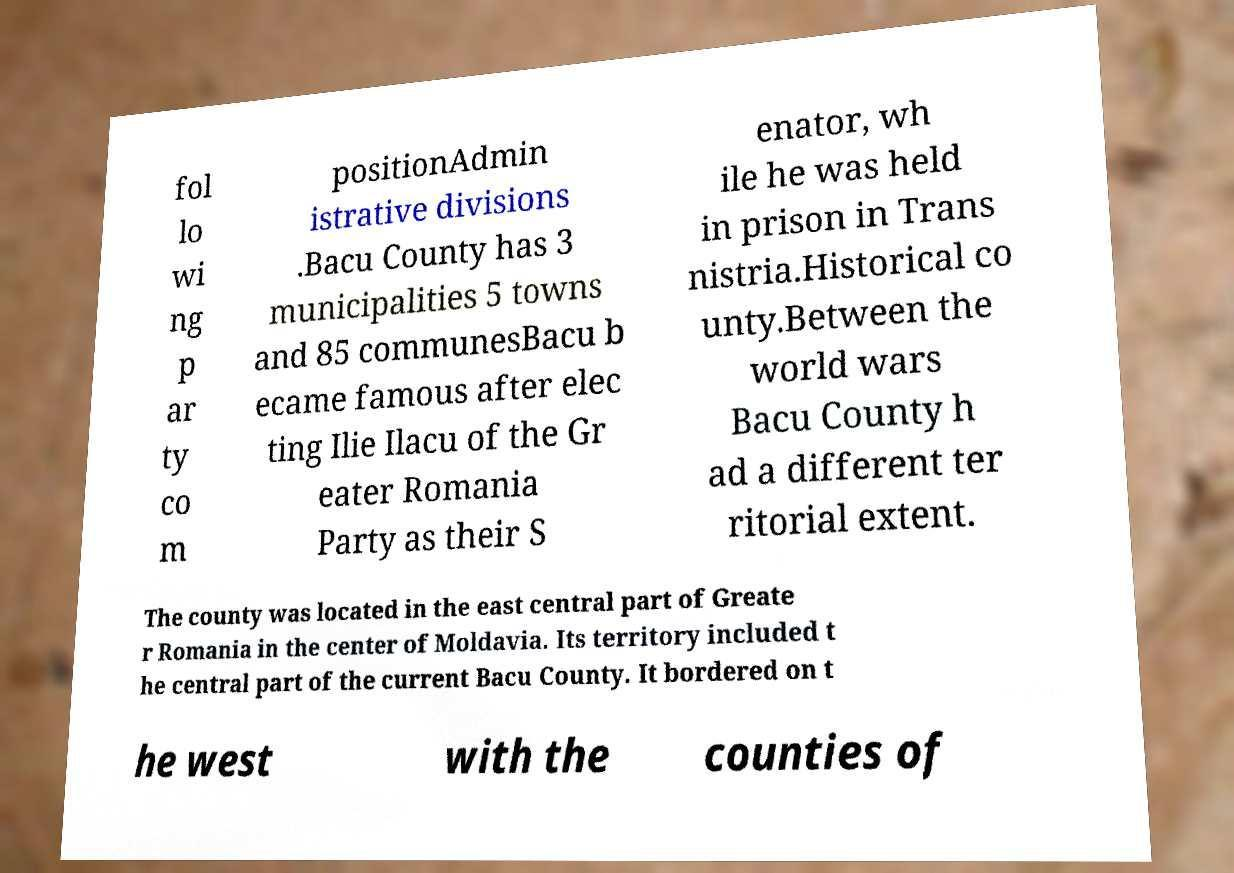Can you read and provide the text displayed in the image?This photo seems to have some interesting text. Can you extract and type it out for me? fol lo wi ng p ar ty co m positionAdmin istrative divisions .Bacu County has 3 municipalities 5 towns and 85 communesBacu b ecame famous after elec ting Ilie Ilacu of the Gr eater Romania Party as their S enator, wh ile he was held in prison in Trans nistria.Historical co unty.Between the world wars Bacu County h ad a different ter ritorial extent. The county was located in the east central part of Greate r Romania in the center of Moldavia. Its territory included t he central part of the current Bacu County. It bordered on t he west with the counties of 